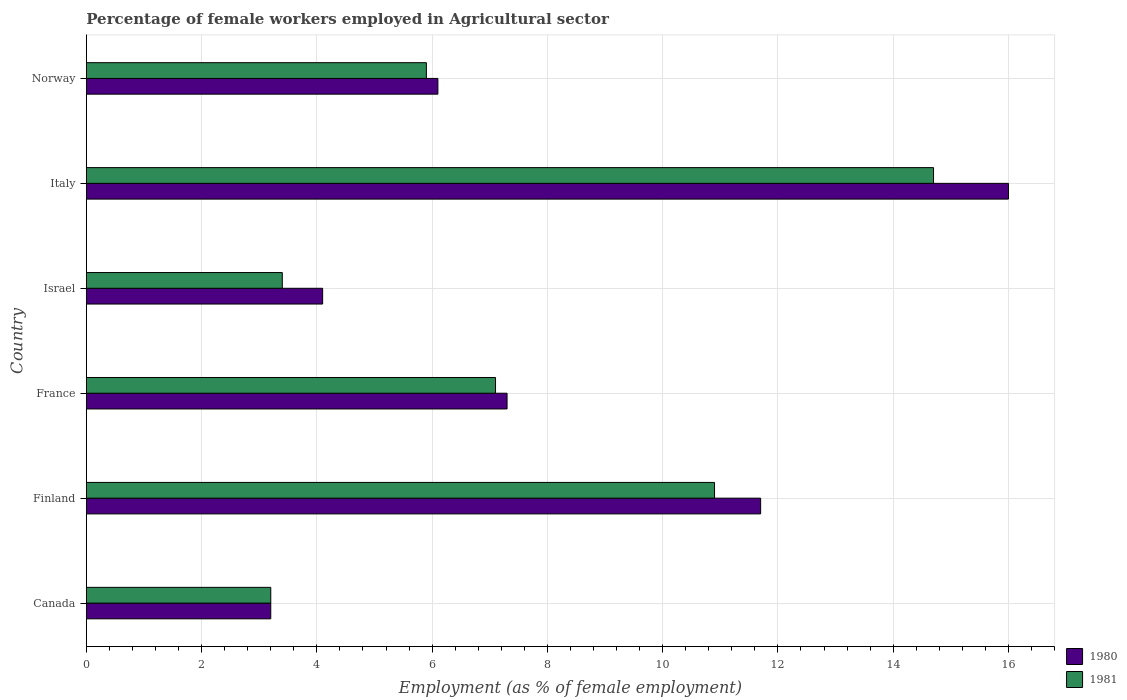How many bars are there on the 5th tick from the top?
Make the answer very short. 2. What is the label of the 1st group of bars from the top?
Make the answer very short. Norway. What is the percentage of females employed in Agricultural sector in 1980 in France?
Make the answer very short. 7.3. Across all countries, what is the maximum percentage of females employed in Agricultural sector in 1981?
Your answer should be very brief. 14.7. Across all countries, what is the minimum percentage of females employed in Agricultural sector in 1980?
Provide a short and direct response. 3.2. What is the total percentage of females employed in Agricultural sector in 1981 in the graph?
Give a very brief answer. 45.2. What is the difference between the percentage of females employed in Agricultural sector in 1981 in Finland and that in Norway?
Your answer should be very brief. 5. What is the difference between the percentage of females employed in Agricultural sector in 1980 in Italy and the percentage of females employed in Agricultural sector in 1981 in Israel?
Offer a very short reply. 12.6. What is the average percentage of females employed in Agricultural sector in 1980 per country?
Provide a succinct answer. 8.07. What is the difference between the percentage of females employed in Agricultural sector in 1981 and percentage of females employed in Agricultural sector in 1980 in France?
Your response must be concise. -0.2. What is the ratio of the percentage of females employed in Agricultural sector in 1981 in Finland to that in Italy?
Your answer should be compact. 0.74. Is the difference between the percentage of females employed in Agricultural sector in 1981 in Finland and France greater than the difference between the percentage of females employed in Agricultural sector in 1980 in Finland and France?
Keep it short and to the point. No. What is the difference between the highest and the second highest percentage of females employed in Agricultural sector in 1981?
Your answer should be compact. 3.8. What is the difference between the highest and the lowest percentage of females employed in Agricultural sector in 1980?
Keep it short and to the point. 12.8. Is the sum of the percentage of females employed in Agricultural sector in 1980 in Italy and Norway greater than the maximum percentage of females employed in Agricultural sector in 1981 across all countries?
Make the answer very short. Yes. What does the 1st bar from the top in Norway represents?
Offer a terse response. 1981. What does the 1st bar from the bottom in France represents?
Your answer should be compact. 1980. How many bars are there?
Your answer should be compact. 12. Are the values on the major ticks of X-axis written in scientific E-notation?
Your answer should be compact. No. Does the graph contain any zero values?
Give a very brief answer. No. Does the graph contain grids?
Your answer should be very brief. Yes. Where does the legend appear in the graph?
Ensure brevity in your answer.  Bottom right. What is the title of the graph?
Make the answer very short. Percentage of female workers employed in Agricultural sector. What is the label or title of the X-axis?
Ensure brevity in your answer.  Employment (as % of female employment). What is the Employment (as % of female employment) of 1980 in Canada?
Offer a very short reply. 3.2. What is the Employment (as % of female employment) in 1981 in Canada?
Ensure brevity in your answer.  3.2. What is the Employment (as % of female employment) of 1980 in Finland?
Ensure brevity in your answer.  11.7. What is the Employment (as % of female employment) in 1981 in Finland?
Give a very brief answer. 10.9. What is the Employment (as % of female employment) of 1980 in France?
Your response must be concise. 7.3. What is the Employment (as % of female employment) of 1981 in France?
Ensure brevity in your answer.  7.1. What is the Employment (as % of female employment) of 1980 in Israel?
Give a very brief answer. 4.1. What is the Employment (as % of female employment) of 1981 in Israel?
Ensure brevity in your answer.  3.4. What is the Employment (as % of female employment) of 1980 in Italy?
Your response must be concise. 16. What is the Employment (as % of female employment) of 1981 in Italy?
Ensure brevity in your answer.  14.7. What is the Employment (as % of female employment) in 1980 in Norway?
Keep it short and to the point. 6.1. What is the Employment (as % of female employment) in 1981 in Norway?
Give a very brief answer. 5.9. Across all countries, what is the maximum Employment (as % of female employment) in 1980?
Your answer should be very brief. 16. Across all countries, what is the maximum Employment (as % of female employment) in 1981?
Offer a terse response. 14.7. Across all countries, what is the minimum Employment (as % of female employment) in 1980?
Your answer should be very brief. 3.2. Across all countries, what is the minimum Employment (as % of female employment) in 1981?
Ensure brevity in your answer.  3.2. What is the total Employment (as % of female employment) of 1980 in the graph?
Your answer should be compact. 48.4. What is the total Employment (as % of female employment) of 1981 in the graph?
Your response must be concise. 45.2. What is the difference between the Employment (as % of female employment) of 1980 in Canada and that in Finland?
Ensure brevity in your answer.  -8.5. What is the difference between the Employment (as % of female employment) of 1981 in Canada and that in Finland?
Your response must be concise. -7.7. What is the difference between the Employment (as % of female employment) of 1980 in Canada and that in France?
Provide a short and direct response. -4.1. What is the difference between the Employment (as % of female employment) in 1980 in Canada and that in Israel?
Your answer should be compact. -0.9. What is the difference between the Employment (as % of female employment) in 1980 in Canada and that in Norway?
Provide a succinct answer. -2.9. What is the difference between the Employment (as % of female employment) of 1980 in Finland and that in Italy?
Give a very brief answer. -4.3. What is the difference between the Employment (as % of female employment) of 1981 in France and that in Israel?
Offer a terse response. 3.7. What is the difference between the Employment (as % of female employment) of 1980 in France and that in Italy?
Keep it short and to the point. -8.7. What is the difference between the Employment (as % of female employment) in 1980 in Israel and that in Italy?
Offer a terse response. -11.9. What is the difference between the Employment (as % of female employment) of 1980 in Israel and that in Norway?
Give a very brief answer. -2. What is the difference between the Employment (as % of female employment) of 1981 in Israel and that in Norway?
Give a very brief answer. -2.5. What is the difference between the Employment (as % of female employment) in 1980 in Canada and the Employment (as % of female employment) in 1981 in Finland?
Provide a short and direct response. -7.7. What is the difference between the Employment (as % of female employment) in 1980 in Canada and the Employment (as % of female employment) in 1981 in Israel?
Keep it short and to the point. -0.2. What is the difference between the Employment (as % of female employment) in 1980 in Canada and the Employment (as % of female employment) in 1981 in Italy?
Provide a short and direct response. -11.5. What is the difference between the Employment (as % of female employment) in 1980 in Canada and the Employment (as % of female employment) in 1981 in Norway?
Give a very brief answer. -2.7. What is the difference between the Employment (as % of female employment) in 1980 in Finland and the Employment (as % of female employment) in 1981 in France?
Give a very brief answer. 4.6. What is the difference between the Employment (as % of female employment) of 1980 in Finland and the Employment (as % of female employment) of 1981 in Israel?
Make the answer very short. 8.3. What is the difference between the Employment (as % of female employment) in 1980 in Finland and the Employment (as % of female employment) in 1981 in Italy?
Ensure brevity in your answer.  -3. What is the difference between the Employment (as % of female employment) of 1980 in France and the Employment (as % of female employment) of 1981 in Norway?
Make the answer very short. 1.4. What is the difference between the Employment (as % of female employment) in 1980 in Israel and the Employment (as % of female employment) in 1981 in Italy?
Make the answer very short. -10.6. What is the difference between the Employment (as % of female employment) in 1980 in Israel and the Employment (as % of female employment) in 1981 in Norway?
Provide a short and direct response. -1.8. What is the average Employment (as % of female employment) of 1980 per country?
Give a very brief answer. 8.07. What is the average Employment (as % of female employment) in 1981 per country?
Offer a very short reply. 7.53. What is the difference between the Employment (as % of female employment) in 1980 and Employment (as % of female employment) in 1981 in Canada?
Keep it short and to the point. 0. What is the difference between the Employment (as % of female employment) in 1980 and Employment (as % of female employment) in 1981 in Italy?
Provide a short and direct response. 1.3. What is the ratio of the Employment (as % of female employment) of 1980 in Canada to that in Finland?
Keep it short and to the point. 0.27. What is the ratio of the Employment (as % of female employment) in 1981 in Canada to that in Finland?
Ensure brevity in your answer.  0.29. What is the ratio of the Employment (as % of female employment) in 1980 in Canada to that in France?
Give a very brief answer. 0.44. What is the ratio of the Employment (as % of female employment) in 1981 in Canada to that in France?
Keep it short and to the point. 0.45. What is the ratio of the Employment (as % of female employment) of 1980 in Canada to that in Israel?
Your answer should be very brief. 0.78. What is the ratio of the Employment (as % of female employment) in 1981 in Canada to that in Israel?
Your answer should be very brief. 0.94. What is the ratio of the Employment (as % of female employment) in 1981 in Canada to that in Italy?
Your answer should be very brief. 0.22. What is the ratio of the Employment (as % of female employment) of 1980 in Canada to that in Norway?
Ensure brevity in your answer.  0.52. What is the ratio of the Employment (as % of female employment) in 1981 in Canada to that in Norway?
Provide a short and direct response. 0.54. What is the ratio of the Employment (as % of female employment) of 1980 in Finland to that in France?
Keep it short and to the point. 1.6. What is the ratio of the Employment (as % of female employment) of 1981 in Finland to that in France?
Offer a terse response. 1.54. What is the ratio of the Employment (as % of female employment) in 1980 in Finland to that in Israel?
Keep it short and to the point. 2.85. What is the ratio of the Employment (as % of female employment) in 1981 in Finland to that in Israel?
Ensure brevity in your answer.  3.21. What is the ratio of the Employment (as % of female employment) in 1980 in Finland to that in Italy?
Keep it short and to the point. 0.73. What is the ratio of the Employment (as % of female employment) in 1981 in Finland to that in Italy?
Provide a succinct answer. 0.74. What is the ratio of the Employment (as % of female employment) of 1980 in Finland to that in Norway?
Make the answer very short. 1.92. What is the ratio of the Employment (as % of female employment) in 1981 in Finland to that in Norway?
Your answer should be compact. 1.85. What is the ratio of the Employment (as % of female employment) of 1980 in France to that in Israel?
Offer a very short reply. 1.78. What is the ratio of the Employment (as % of female employment) in 1981 in France to that in Israel?
Your answer should be very brief. 2.09. What is the ratio of the Employment (as % of female employment) in 1980 in France to that in Italy?
Keep it short and to the point. 0.46. What is the ratio of the Employment (as % of female employment) of 1981 in France to that in Italy?
Your answer should be very brief. 0.48. What is the ratio of the Employment (as % of female employment) in 1980 in France to that in Norway?
Offer a terse response. 1.2. What is the ratio of the Employment (as % of female employment) of 1981 in France to that in Norway?
Give a very brief answer. 1.2. What is the ratio of the Employment (as % of female employment) of 1980 in Israel to that in Italy?
Your response must be concise. 0.26. What is the ratio of the Employment (as % of female employment) of 1981 in Israel to that in Italy?
Provide a succinct answer. 0.23. What is the ratio of the Employment (as % of female employment) in 1980 in Israel to that in Norway?
Give a very brief answer. 0.67. What is the ratio of the Employment (as % of female employment) of 1981 in Israel to that in Norway?
Provide a succinct answer. 0.58. What is the ratio of the Employment (as % of female employment) in 1980 in Italy to that in Norway?
Offer a terse response. 2.62. What is the ratio of the Employment (as % of female employment) in 1981 in Italy to that in Norway?
Your response must be concise. 2.49. What is the difference between the highest and the second highest Employment (as % of female employment) of 1981?
Offer a terse response. 3.8. 